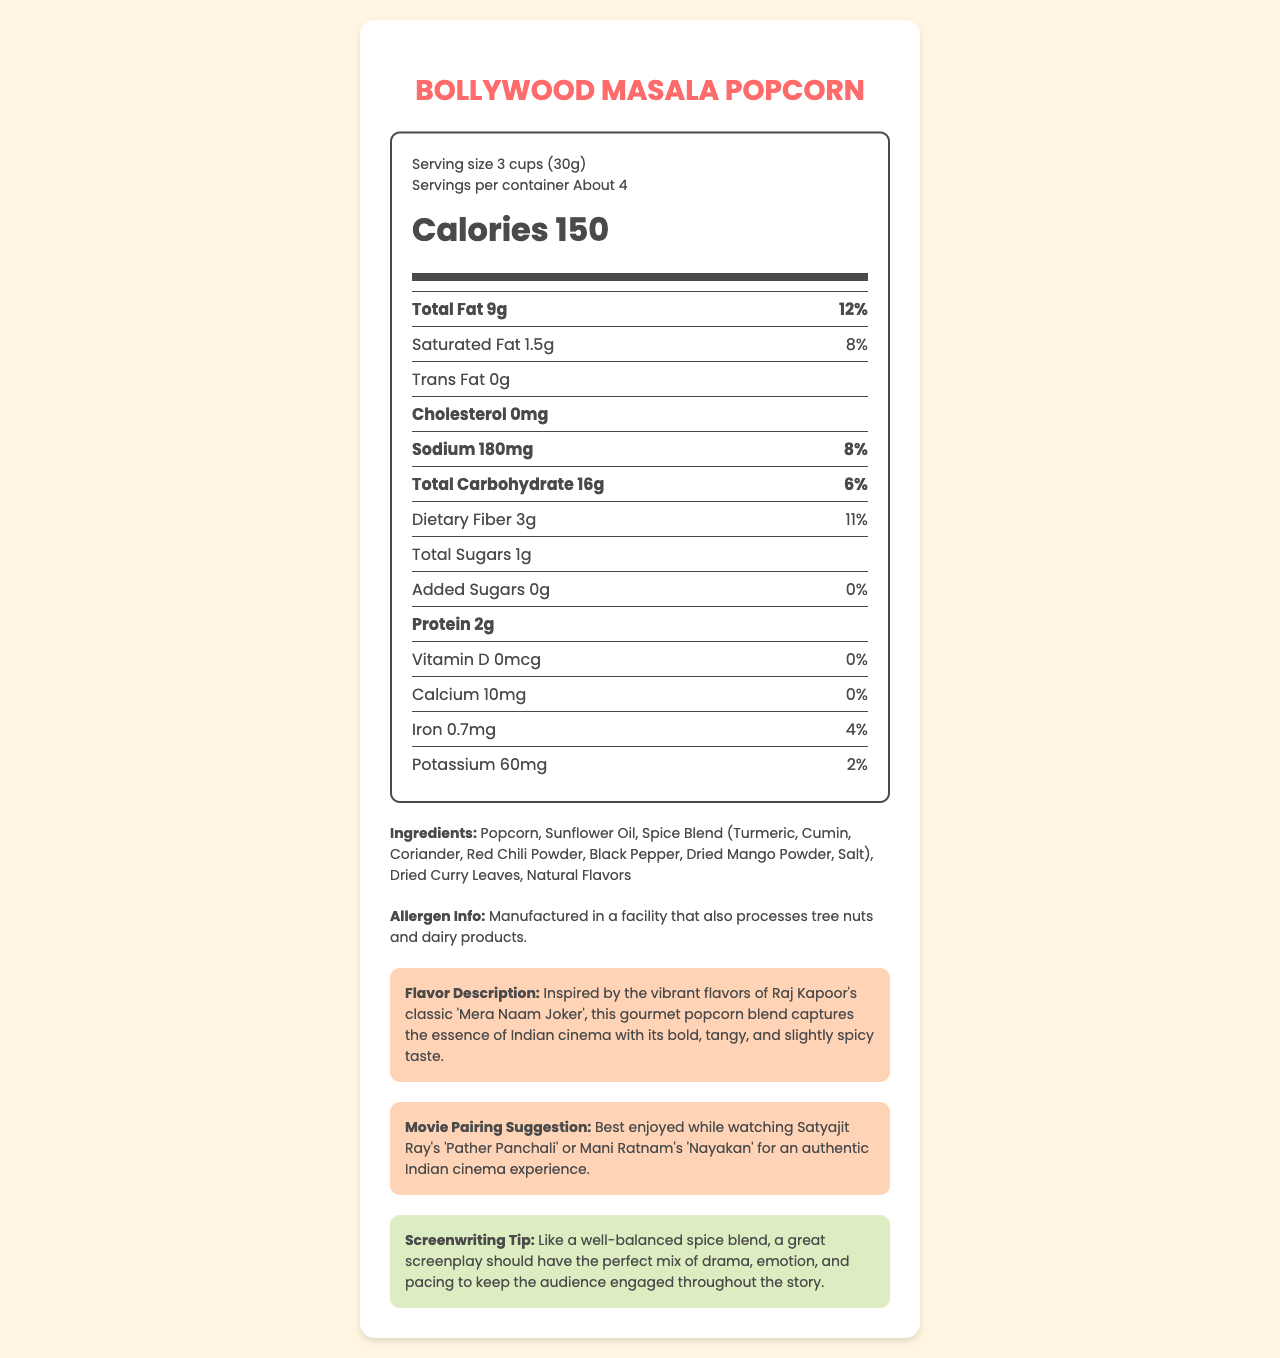what is the serving size of Bollywood Masala Popcorn? The serving size is listed as 3 cups (30g) in the document.
Answer: 3 cups (30g) how many calories are in one serving of Bollywood Masala Popcorn? The calories per serving are shown as 150 in the document.
Answer: 150 what is the total fat content per serving? The total fat per serving is listed as 9g in the document.
Answer: 9g how much dietary fiber is in each serving? Dietary fiber per serving is listed as 3g.
Answer: 3g how much sodium is in each serving? Sodium content per serving is indicated as 180mg.
Answer: 180mg Is there any trans fat in Bollywood Masala Popcorn? The document lists trans fat content as 0g per serving, which means there is none.
Answer: No What is a suitable movie to pair with Bollywood Masala Popcorn? The movie pairing suggestion in the document recommends watching either Satyajit Ray's 'Pather Panchali' or Mani Ratnam's 'Nayakan'.
Answer: Pather Panchali or Nayakan how much protein is in one serving? A. 1g B. 2g C. 3g D. 4g The document lists protein content as 2g per serving.
Answer: B which of the following ingredients is NOT listed for Bollywood Masala Popcorn? A. Sunflower Oil B. Spice Blend C. Brown Sugar D. Popcorn Brown sugar is not listed in the ingredients. The document lists Sunflower Oil, Spice Blend, and Popcorn among the ingredients.
Answer: C is Bollywood Masala Popcorn suitable for people with tree nut allergies? The allergen info section states it is manufactured in a facility that also processes tree nuts.
Answer: No describe the flavor of Bollywood Masala Popcorn The flavor description notes that it captures the essence of Indian cinema with a bold, tangy, and slightly spicy taste.
Answer: Bold, tangy, and slightly spicy with inspiration from classic Indian cinema what is the main idea of the document? The document provides detailed nutritional information, ingredient list, flavor description, movie pairings, and screenwriting tip related to Bollywood Masala Popcorn.
Answer: Nutritional information and flavor description of Bollywood Masala Popcorn how much vitamin D is in Bollywood Masala Popcorn? The document states that the vitamin D content per serving is 0mcg.
Answer: 0mcg does Bollywood Masala Popcorn contain added sugars? The document notes that added sugars per serving are 0g, meaning there are no added sugars in the popcorn.
Answer: No what classic Indian film inspired the flavor of Bollywood Masala Popcorn? The flavor description mentions that it is inspired by Raj Kapoor's classic film 'Mera Naam Joker'.
Answer: Mera Naam Joker what is the daily value percentage of iron per serving? The document indicates that one serving of the popcorn provides 4% of the daily value of iron.
Answer: 4% how is a great screenplay compared to Bollywood Masala Popcorn? The screenwriting tip suggests that, like a well-balanced spice blend, a great screenplay should have the perfect mix of drama, emotion, and pacing.
Answer: A well-balanced spice blend how many servings are in a container? The document indicates that there are about 4 servings per container.
Answer: About 4 what is the exact amount of calcium in Bollywood Masala Popcorn per serving? The amount of calcium per serving is listed as 10mg.
Answer: 10mg what is the usual price of Bollywood Masala Popcorn? The document does not provide any information about the price of the popcorn.
Answer: Cannot be determined 